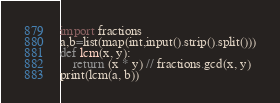<code> <loc_0><loc_0><loc_500><loc_500><_Python_>import fractions
a,b=list(map(int,input().strip().split()))
def lcm(x, y):
    return (x * y) // fractions.gcd(x, y)
print(lcm(a, b))</code> 